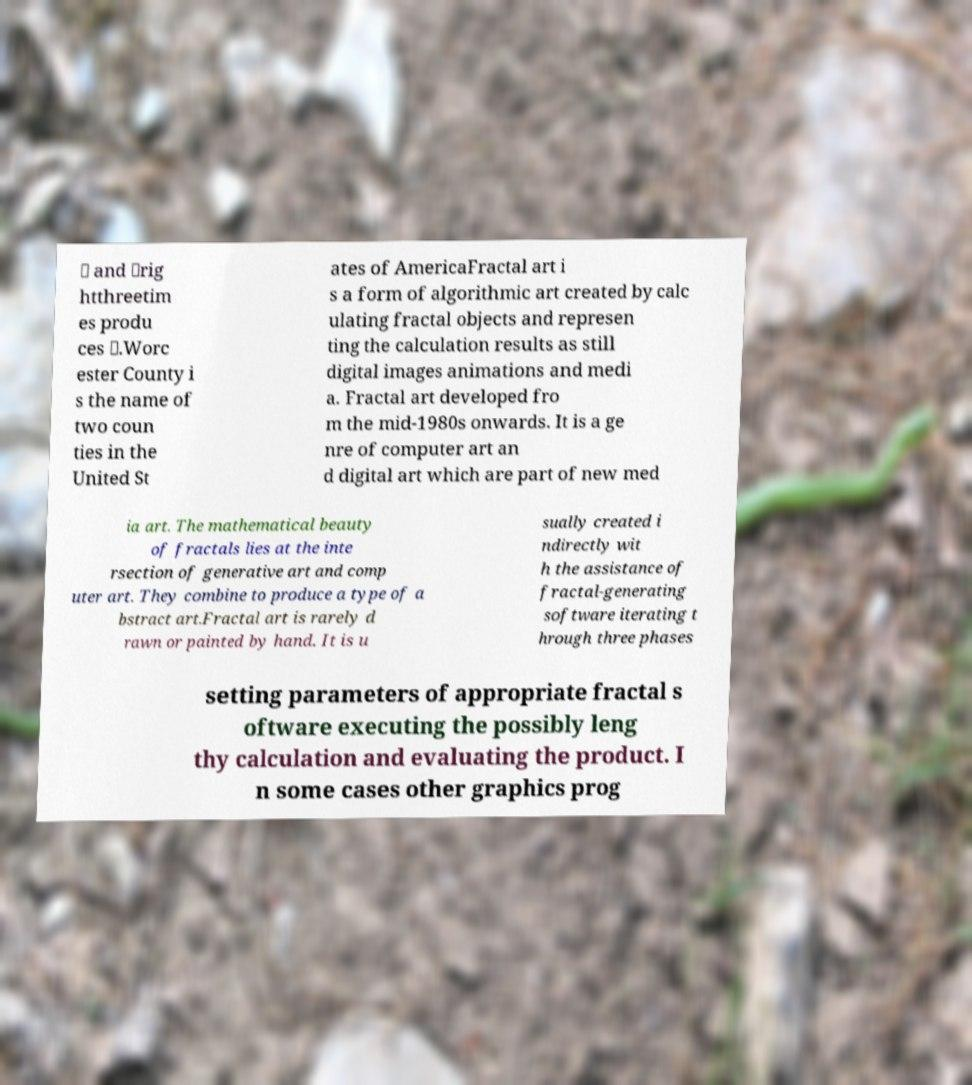I need the written content from this picture converted into text. Can you do that? ⋋ and \rig htthreetim es produ ces ⋌.Worc ester County i s the name of two coun ties in the United St ates of AmericaFractal art i s a form of algorithmic art created by calc ulating fractal objects and represen ting the calculation results as still digital images animations and medi a. Fractal art developed fro m the mid-1980s onwards. It is a ge nre of computer art an d digital art which are part of new med ia art. The mathematical beauty of fractals lies at the inte rsection of generative art and comp uter art. They combine to produce a type of a bstract art.Fractal art is rarely d rawn or painted by hand. It is u sually created i ndirectly wit h the assistance of fractal-generating software iterating t hrough three phases setting parameters of appropriate fractal s oftware executing the possibly leng thy calculation and evaluating the product. I n some cases other graphics prog 